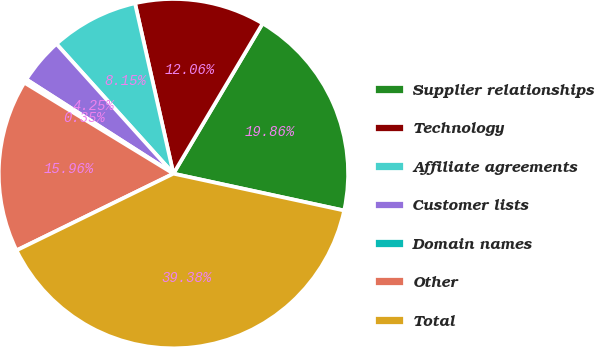Convert chart to OTSL. <chart><loc_0><loc_0><loc_500><loc_500><pie_chart><fcel>Supplier relationships<fcel>Technology<fcel>Affiliate agreements<fcel>Customer lists<fcel>Domain names<fcel>Other<fcel>Total<nl><fcel>19.86%<fcel>12.06%<fcel>8.15%<fcel>4.25%<fcel>0.35%<fcel>15.96%<fcel>39.38%<nl></chart> 